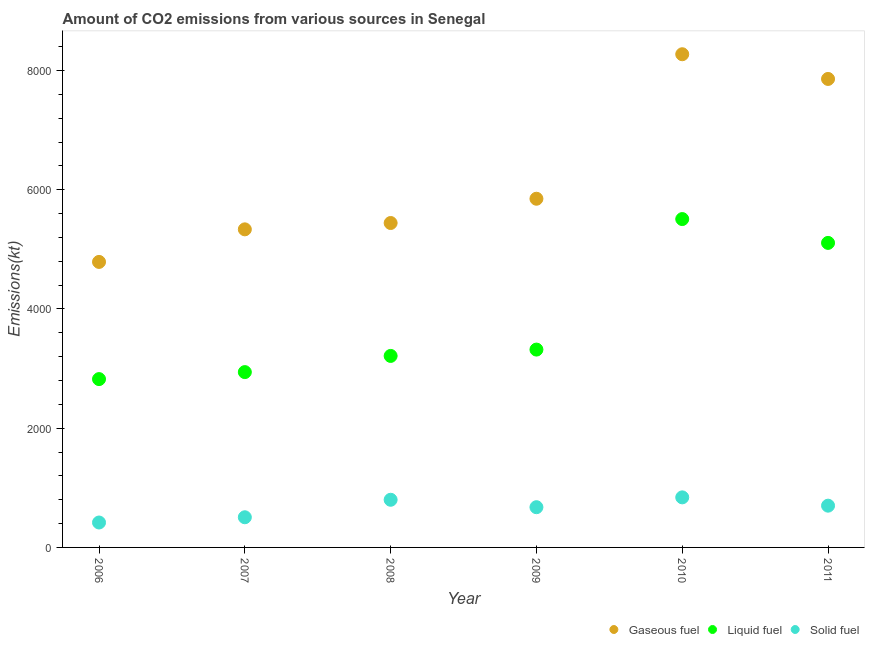How many different coloured dotlines are there?
Make the answer very short. 3. Is the number of dotlines equal to the number of legend labels?
Your answer should be very brief. Yes. What is the amount of co2 emissions from gaseous fuel in 2011?
Provide a short and direct response. 7858.38. Across all years, what is the maximum amount of co2 emissions from gaseous fuel?
Provide a succinct answer. 8272.75. Across all years, what is the minimum amount of co2 emissions from liquid fuel?
Ensure brevity in your answer.  2823.59. In which year was the amount of co2 emissions from gaseous fuel maximum?
Your answer should be very brief. 2010. In which year was the amount of co2 emissions from solid fuel minimum?
Ensure brevity in your answer.  2006. What is the total amount of co2 emissions from gaseous fuel in the graph?
Provide a succinct answer. 3.75e+04. What is the difference between the amount of co2 emissions from liquid fuel in 2007 and that in 2009?
Offer a terse response. -377.7. What is the difference between the amount of co2 emissions from gaseous fuel in 2006 and the amount of co2 emissions from solid fuel in 2008?
Provide a short and direct response. 3989.7. What is the average amount of co2 emissions from solid fuel per year?
Ensure brevity in your answer.  656.39. In the year 2007, what is the difference between the amount of co2 emissions from solid fuel and amount of co2 emissions from gaseous fuel?
Make the answer very short. -4829.44. In how many years, is the amount of co2 emissions from solid fuel greater than 1200 kt?
Your answer should be very brief. 0. What is the ratio of the amount of co2 emissions from solid fuel in 2008 to that in 2010?
Offer a very short reply. 0.95. Is the amount of co2 emissions from liquid fuel in 2007 less than that in 2011?
Offer a terse response. Yes. What is the difference between the highest and the second highest amount of co2 emissions from gaseous fuel?
Your answer should be compact. 414.37. What is the difference between the highest and the lowest amount of co2 emissions from gaseous fuel?
Your answer should be compact. 3483.65. In how many years, is the amount of co2 emissions from gaseous fuel greater than the average amount of co2 emissions from gaseous fuel taken over all years?
Keep it short and to the point. 2. Is the sum of the amount of co2 emissions from liquid fuel in 2010 and 2011 greater than the maximum amount of co2 emissions from solid fuel across all years?
Your answer should be very brief. Yes. Is the amount of co2 emissions from liquid fuel strictly greater than the amount of co2 emissions from solid fuel over the years?
Your answer should be compact. Yes. How many dotlines are there?
Offer a terse response. 3. What is the difference between two consecutive major ticks on the Y-axis?
Give a very brief answer. 2000. Are the values on the major ticks of Y-axis written in scientific E-notation?
Provide a succinct answer. No. Does the graph contain any zero values?
Make the answer very short. No. Where does the legend appear in the graph?
Give a very brief answer. Bottom right. What is the title of the graph?
Give a very brief answer. Amount of CO2 emissions from various sources in Senegal. Does "Capital account" appear as one of the legend labels in the graph?
Provide a short and direct response. No. What is the label or title of the X-axis?
Your answer should be very brief. Year. What is the label or title of the Y-axis?
Keep it short and to the point. Emissions(kt). What is the Emissions(kt) of Gaseous fuel in 2006?
Provide a short and direct response. 4789.1. What is the Emissions(kt) of Liquid fuel in 2006?
Give a very brief answer. 2823.59. What is the Emissions(kt) in Solid fuel in 2006?
Provide a succinct answer. 418.04. What is the Emissions(kt) in Gaseous fuel in 2007?
Offer a terse response. 5335.48. What is the Emissions(kt) of Liquid fuel in 2007?
Offer a terse response. 2940.93. What is the Emissions(kt) in Solid fuel in 2007?
Offer a very short reply. 506.05. What is the Emissions(kt) of Gaseous fuel in 2008?
Offer a very short reply. 5441.83. What is the Emissions(kt) of Liquid fuel in 2008?
Offer a very short reply. 3212.29. What is the Emissions(kt) of Solid fuel in 2008?
Your answer should be compact. 799.41. What is the Emissions(kt) of Gaseous fuel in 2009?
Give a very brief answer. 5848.86. What is the Emissions(kt) in Liquid fuel in 2009?
Offer a very short reply. 3318.64. What is the Emissions(kt) of Solid fuel in 2009?
Give a very brief answer. 674.73. What is the Emissions(kt) in Gaseous fuel in 2010?
Offer a very short reply. 8272.75. What is the Emissions(kt) of Liquid fuel in 2010?
Offer a terse response. 5507.83. What is the Emissions(kt) of Solid fuel in 2010?
Keep it short and to the point. 839.74. What is the Emissions(kt) in Gaseous fuel in 2011?
Make the answer very short. 7858.38. What is the Emissions(kt) of Liquid fuel in 2011?
Offer a very short reply. 5108.13. What is the Emissions(kt) in Solid fuel in 2011?
Provide a short and direct response. 700.4. Across all years, what is the maximum Emissions(kt) of Gaseous fuel?
Your response must be concise. 8272.75. Across all years, what is the maximum Emissions(kt) in Liquid fuel?
Your answer should be compact. 5507.83. Across all years, what is the maximum Emissions(kt) in Solid fuel?
Offer a terse response. 839.74. Across all years, what is the minimum Emissions(kt) of Gaseous fuel?
Keep it short and to the point. 4789.1. Across all years, what is the minimum Emissions(kt) of Liquid fuel?
Offer a very short reply. 2823.59. Across all years, what is the minimum Emissions(kt) in Solid fuel?
Offer a terse response. 418.04. What is the total Emissions(kt) of Gaseous fuel in the graph?
Give a very brief answer. 3.75e+04. What is the total Emissions(kt) of Liquid fuel in the graph?
Offer a very short reply. 2.29e+04. What is the total Emissions(kt) in Solid fuel in the graph?
Your response must be concise. 3938.36. What is the difference between the Emissions(kt) in Gaseous fuel in 2006 and that in 2007?
Your answer should be compact. -546.38. What is the difference between the Emissions(kt) of Liquid fuel in 2006 and that in 2007?
Give a very brief answer. -117.34. What is the difference between the Emissions(kt) of Solid fuel in 2006 and that in 2007?
Your answer should be compact. -88.01. What is the difference between the Emissions(kt) of Gaseous fuel in 2006 and that in 2008?
Provide a succinct answer. -652.73. What is the difference between the Emissions(kt) of Liquid fuel in 2006 and that in 2008?
Provide a short and direct response. -388.7. What is the difference between the Emissions(kt) of Solid fuel in 2006 and that in 2008?
Offer a terse response. -381.37. What is the difference between the Emissions(kt) in Gaseous fuel in 2006 and that in 2009?
Ensure brevity in your answer.  -1059.76. What is the difference between the Emissions(kt) of Liquid fuel in 2006 and that in 2009?
Offer a very short reply. -495.05. What is the difference between the Emissions(kt) of Solid fuel in 2006 and that in 2009?
Offer a very short reply. -256.69. What is the difference between the Emissions(kt) of Gaseous fuel in 2006 and that in 2010?
Give a very brief answer. -3483.65. What is the difference between the Emissions(kt) of Liquid fuel in 2006 and that in 2010?
Provide a short and direct response. -2684.24. What is the difference between the Emissions(kt) of Solid fuel in 2006 and that in 2010?
Give a very brief answer. -421.7. What is the difference between the Emissions(kt) in Gaseous fuel in 2006 and that in 2011?
Keep it short and to the point. -3069.28. What is the difference between the Emissions(kt) in Liquid fuel in 2006 and that in 2011?
Your response must be concise. -2284.54. What is the difference between the Emissions(kt) of Solid fuel in 2006 and that in 2011?
Ensure brevity in your answer.  -282.36. What is the difference between the Emissions(kt) in Gaseous fuel in 2007 and that in 2008?
Keep it short and to the point. -106.34. What is the difference between the Emissions(kt) of Liquid fuel in 2007 and that in 2008?
Your response must be concise. -271.36. What is the difference between the Emissions(kt) of Solid fuel in 2007 and that in 2008?
Your answer should be compact. -293.36. What is the difference between the Emissions(kt) of Gaseous fuel in 2007 and that in 2009?
Ensure brevity in your answer.  -513.38. What is the difference between the Emissions(kt) in Liquid fuel in 2007 and that in 2009?
Make the answer very short. -377.7. What is the difference between the Emissions(kt) of Solid fuel in 2007 and that in 2009?
Ensure brevity in your answer.  -168.68. What is the difference between the Emissions(kt) of Gaseous fuel in 2007 and that in 2010?
Your response must be concise. -2937.27. What is the difference between the Emissions(kt) in Liquid fuel in 2007 and that in 2010?
Keep it short and to the point. -2566.9. What is the difference between the Emissions(kt) of Solid fuel in 2007 and that in 2010?
Your response must be concise. -333.7. What is the difference between the Emissions(kt) of Gaseous fuel in 2007 and that in 2011?
Keep it short and to the point. -2522.9. What is the difference between the Emissions(kt) in Liquid fuel in 2007 and that in 2011?
Offer a terse response. -2167.2. What is the difference between the Emissions(kt) in Solid fuel in 2007 and that in 2011?
Keep it short and to the point. -194.35. What is the difference between the Emissions(kt) of Gaseous fuel in 2008 and that in 2009?
Your answer should be very brief. -407.04. What is the difference between the Emissions(kt) in Liquid fuel in 2008 and that in 2009?
Your answer should be very brief. -106.34. What is the difference between the Emissions(kt) in Solid fuel in 2008 and that in 2009?
Offer a terse response. 124.68. What is the difference between the Emissions(kt) of Gaseous fuel in 2008 and that in 2010?
Provide a succinct answer. -2830.92. What is the difference between the Emissions(kt) in Liquid fuel in 2008 and that in 2010?
Provide a short and direct response. -2295.54. What is the difference between the Emissions(kt) in Solid fuel in 2008 and that in 2010?
Your response must be concise. -40.34. What is the difference between the Emissions(kt) in Gaseous fuel in 2008 and that in 2011?
Your response must be concise. -2416.55. What is the difference between the Emissions(kt) of Liquid fuel in 2008 and that in 2011?
Provide a succinct answer. -1895.84. What is the difference between the Emissions(kt) of Solid fuel in 2008 and that in 2011?
Offer a very short reply. 99.01. What is the difference between the Emissions(kt) in Gaseous fuel in 2009 and that in 2010?
Offer a terse response. -2423.89. What is the difference between the Emissions(kt) of Liquid fuel in 2009 and that in 2010?
Keep it short and to the point. -2189.2. What is the difference between the Emissions(kt) in Solid fuel in 2009 and that in 2010?
Make the answer very short. -165.01. What is the difference between the Emissions(kt) in Gaseous fuel in 2009 and that in 2011?
Provide a succinct answer. -2009.52. What is the difference between the Emissions(kt) in Liquid fuel in 2009 and that in 2011?
Ensure brevity in your answer.  -1789.5. What is the difference between the Emissions(kt) of Solid fuel in 2009 and that in 2011?
Give a very brief answer. -25.67. What is the difference between the Emissions(kt) of Gaseous fuel in 2010 and that in 2011?
Provide a succinct answer. 414.37. What is the difference between the Emissions(kt) of Liquid fuel in 2010 and that in 2011?
Offer a terse response. 399.7. What is the difference between the Emissions(kt) in Solid fuel in 2010 and that in 2011?
Offer a very short reply. 139.35. What is the difference between the Emissions(kt) in Gaseous fuel in 2006 and the Emissions(kt) in Liquid fuel in 2007?
Keep it short and to the point. 1848.17. What is the difference between the Emissions(kt) of Gaseous fuel in 2006 and the Emissions(kt) of Solid fuel in 2007?
Keep it short and to the point. 4283.06. What is the difference between the Emissions(kt) of Liquid fuel in 2006 and the Emissions(kt) of Solid fuel in 2007?
Ensure brevity in your answer.  2317.54. What is the difference between the Emissions(kt) of Gaseous fuel in 2006 and the Emissions(kt) of Liquid fuel in 2008?
Your answer should be compact. 1576.81. What is the difference between the Emissions(kt) in Gaseous fuel in 2006 and the Emissions(kt) in Solid fuel in 2008?
Offer a terse response. 3989.7. What is the difference between the Emissions(kt) in Liquid fuel in 2006 and the Emissions(kt) in Solid fuel in 2008?
Offer a terse response. 2024.18. What is the difference between the Emissions(kt) of Gaseous fuel in 2006 and the Emissions(kt) of Liquid fuel in 2009?
Offer a very short reply. 1470.47. What is the difference between the Emissions(kt) in Gaseous fuel in 2006 and the Emissions(kt) in Solid fuel in 2009?
Provide a short and direct response. 4114.37. What is the difference between the Emissions(kt) of Liquid fuel in 2006 and the Emissions(kt) of Solid fuel in 2009?
Your answer should be compact. 2148.86. What is the difference between the Emissions(kt) of Gaseous fuel in 2006 and the Emissions(kt) of Liquid fuel in 2010?
Your answer should be very brief. -718.73. What is the difference between the Emissions(kt) in Gaseous fuel in 2006 and the Emissions(kt) in Solid fuel in 2010?
Offer a very short reply. 3949.36. What is the difference between the Emissions(kt) of Liquid fuel in 2006 and the Emissions(kt) of Solid fuel in 2010?
Your answer should be very brief. 1983.85. What is the difference between the Emissions(kt) of Gaseous fuel in 2006 and the Emissions(kt) of Liquid fuel in 2011?
Your answer should be compact. -319.03. What is the difference between the Emissions(kt) in Gaseous fuel in 2006 and the Emissions(kt) in Solid fuel in 2011?
Your answer should be compact. 4088.7. What is the difference between the Emissions(kt) of Liquid fuel in 2006 and the Emissions(kt) of Solid fuel in 2011?
Offer a very short reply. 2123.19. What is the difference between the Emissions(kt) in Gaseous fuel in 2007 and the Emissions(kt) in Liquid fuel in 2008?
Your answer should be compact. 2123.19. What is the difference between the Emissions(kt) of Gaseous fuel in 2007 and the Emissions(kt) of Solid fuel in 2008?
Provide a succinct answer. 4536.08. What is the difference between the Emissions(kt) of Liquid fuel in 2007 and the Emissions(kt) of Solid fuel in 2008?
Keep it short and to the point. 2141.53. What is the difference between the Emissions(kt) of Gaseous fuel in 2007 and the Emissions(kt) of Liquid fuel in 2009?
Give a very brief answer. 2016.85. What is the difference between the Emissions(kt) in Gaseous fuel in 2007 and the Emissions(kt) in Solid fuel in 2009?
Ensure brevity in your answer.  4660.76. What is the difference between the Emissions(kt) in Liquid fuel in 2007 and the Emissions(kt) in Solid fuel in 2009?
Offer a very short reply. 2266.21. What is the difference between the Emissions(kt) of Gaseous fuel in 2007 and the Emissions(kt) of Liquid fuel in 2010?
Your answer should be compact. -172.35. What is the difference between the Emissions(kt) of Gaseous fuel in 2007 and the Emissions(kt) of Solid fuel in 2010?
Provide a succinct answer. 4495.74. What is the difference between the Emissions(kt) of Liquid fuel in 2007 and the Emissions(kt) of Solid fuel in 2010?
Your answer should be very brief. 2101.19. What is the difference between the Emissions(kt) in Gaseous fuel in 2007 and the Emissions(kt) in Liquid fuel in 2011?
Your answer should be compact. 227.35. What is the difference between the Emissions(kt) in Gaseous fuel in 2007 and the Emissions(kt) in Solid fuel in 2011?
Your response must be concise. 4635.09. What is the difference between the Emissions(kt) of Liquid fuel in 2007 and the Emissions(kt) of Solid fuel in 2011?
Offer a very short reply. 2240.54. What is the difference between the Emissions(kt) in Gaseous fuel in 2008 and the Emissions(kt) in Liquid fuel in 2009?
Keep it short and to the point. 2123.19. What is the difference between the Emissions(kt) in Gaseous fuel in 2008 and the Emissions(kt) in Solid fuel in 2009?
Ensure brevity in your answer.  4767.1. What is the difference between the Emissions(kt) of Liquid fuel in 2008 and the Emissions(kt) of Solid fuel in 2009?
Ensure brevity in your answer.  2537.56. What is the difference between the Emissions(kt) of Gaseous fuel in 2008 and the Emissions(kt) of Liquid fuel in 2010?
Keep it short and to the point. -66.01. What is the difference between the Emissions(kt) of Gaseous fuel in 2008 and the Emissions(kt) of Solid fuel in 2010?
Your answer should be very brief. 4602.09. What is the difference between the Emissions(kt) of Liquid fuel in 2008 and the Emissions(kt) of Solid fuel in 2010?
Your answer should be very brief. 2372.55. What is the difference between the Emissions(kt) in Gaseous fuel in 2008 and the Emissions(kt) in Liquid fuel in 2011?
Make the answer very short. 333.7. What is the difference between the Emissions(kt) of Gaseous fuel in 2008 and the Emissions(kt) of Solid fuel in 2011?
Keep it short and to the point. 4741.43. What is the difference between the Emissions(kt) of Liquid fuel in 2008 and the Emissions(kt) of Solid fuel in 2011?
Provide a succinct answer. 2511.89. What is the difference between the Emissions(kt) in Gaseous fuel in 2009 and the Emissions(kt) in Liquid fuel in 2010?
Provide a succinct answer. 341.03. What is the difference between the Emissions(kt) of Gaseous fuel in 2009 and the Emissions(kt) of Solid fuel in 2010?
Provide a succinct answer. 5009.12. What is the difference between the Emissions(kt) of Liquid fuel in 2009 and the Emissions(kt) of Solid fuel in 2010?
Offer a terse response. 2478.89. What is the difference between the Emissions(kt) of Gaseous fuel in 2009 and the Emissions(kt) of Liquid fuel in 2011?
Offer a very short reply. 740.73. What is the difference between the Emissions(kt) of Gaseous fuel in 2009 and the Emissions(kt) of Solid fuel in 2011?
Your answer should be very brief. 5148.47. What is the difference between the Emissions(kt) of Liquid fuel in 2009 and the Emissions(kt) of Solid fuel in 2011?
Your response must be concise. 2618.24. What is the difference between the Emissions(kt) in Gaseous fuel in 2010 and the Emissions(kt) in Liquid fuel in 2011?
Offer a very short reply. 3164.62. What is the difference between the Emissions(kt) in Gaseous fuel in 2010 and the Emissions(kt) in Solid fuel in 2011?
Provide a short and direct response. 7572.35. What is the difference between the Emissions(kt) in Liquid fuel in 2010 and the Emissions(kt) in Solid fuel in 2011?
Ensure brevity in your answer.  4807.44. What is the average Emissions(kt) of Gaseous fuel per year?
Give a very brief answer. 6257.74. What is the average Emissions(kt) in Liquid fuel per year?
Your answer should be compact. 3818.57. What is the average Emissions(kt) in Solid fuel per year?
Provide a short and direct response. 656.39. In the year 2006, what is the difference between the Emissions(kt) in Gaseous fuel and Emissions(kt) in Liquid fuel?
Your answer should be compact. 1965.51. In the year 2006, what is the difference between the Emissions(kt) of Gaseous fuel and Emissions(kt) of Solid fuel?
Your answer should be compact. 4371.06. In the year 2006, what is the difference between the Emissions(kt) of Liquid fuel and Emissions(kt) of Solid fuel?
Provide a succinct answer. 2405.55. In the year 2007, what is the difference between the Emissions(kt) of Gaseous fuel and Emissions(kt) of Liquid fuel?
Provide a succinct answer. 2394.55. In the year 2007, what is the difference between the Emissions(kt) of Gaseous fuel and Emissions(kt) of Solid fuel?
Ensure brevity in your answer.  4829.44. In the year 2007, what is the difference between the Emissions(kt) in Liquid fuel and Emissions(kt) in Solid fuel?
Make the answer very short. 2434.89. In the year 2008, what is the difference between the Emissions(kt) of Gaseous fuel and Emissions(kt) of Liquid fuel?
Give a very brief answer. 2229.54. In the year 2008, what is the difference between the Emissions(kt) of Gaseous fuel and Emissions(kt) of Solid fuel?
Ensure brevity in your answer.  4642.42. In the year 2008, what is the difference between the Emissions(kt) of Liquid fuel and Emissions(kt) of Solid fuel?
Provide a short and direct response. 2412.89. In the year 2009, what is the difference between the Emissions(kt) of Gaseous fuel and Emissions(kt) of Liquid fuel?
Your response must be concise. 2530.23. In the year 2009, what is the difference between the Emissions(kt) in Gaseous fuel and Emissions(kt) in Solid fuel?
Your answer should be compact. 5174.14. In the year 2009, what is the difference between the Emissions(kt) in Liquid fuel and Emissions(kt) in Solid fuel?
Your response must be concise. 2643.91. In the year 2010, what is the difference between the Emissions(kt) in Gaseous fuel and Emissions(kt) in Liquid fuel?
Give a very brief answer. 2764.92. In the year 2010, what is the difference between the Emissions(kt) in Gaseous fuel and Emissions(kt) in Solid fuel?
Your response must be concise. 7433.01. In the year 2010, what is the difference between the Emissions(kt) in Liquid fuel and Emissions(kt) in Solid fuel?
Provide a succinct answer. 4668.09. In the year 2011, what is the difference between the Emissions(kt) in Gaseous fuel and Emissions(kt) in Liquid fuel?
Your response must be concise. 2750.25. In the year 2011, what is the difference between the Emissions(kt) in Gaseous fuel and Emissions(kt) in Solid fuel?
Ensure brevity in your answer.  7157.98. In the year 2011, what is the difference between the Emissions(kt) in Liquid fuel and Emissions(kt) in Solid fuel?
Offer a terse response. 4407.73. What is the ratio of the Emissions(kt) of Gaseous fuel in 2006 to that in 2007?
Provide a short and direct response. 0.9. What is the ratio of the Emissions(kt) of Liquid fuel in 2006 to that in 2007?
Offer a very short reply. 0.96. What is the ratio of the Emissions(kt) of Solid fuel in 2006 to that in 2007?
Ensure brevity in your answer.  0.83. What is the ratio of the Emissions(kt) in Gaseous fuel in 2006 to that in 2008?
Provide a succinct answer. 0.88. What is the ratio of the Emissions(kt) of Liquid fuel in 2006 to that in 2008?
Offer a terse response. 0.88. What is the ratio of the Emissions(kt) of Solid fuel in 2006 to that in 2008?
Provide a short and direct response. 0.52. What is the ratio of the Emissions(kt) in Gaseous fuel in 2006 to that in 2009?
Your answer should be very brief. 0.82. What is the ratio of the Emissions(kt) of Liquid fuel in 2006 to that in 2009?
Your answer should be very brief. 0.85. What is the ratio of the Emissions(kt) in Solid fuel in 2006 to that in 2009?
Provide a succinct answer. 0.62. What is the ratio of the Emissions(kt) of Gaseous fuel in 2006 to that in 2010?
Offer a very short reply. 0.58. What is the ratio of the Emissions(kt) of Liquid fuel in 2006 to that in 2010?
Provide a succinct answer. 0.51. What is the ratio of the Emissions(kt) of Solid fuel in 2006 to that in 2010?
Your answer should be compact. 0.5. What is the ratio of the Emissions(kt) in Gaseous fuel in 2006 to that in 2011?
Provide a short and direct response. 0.61. What is the ratio of the Emissions(kt) of Liquid fuel in 2006 to that in 2011?
Provide a succinct answer. 0.55. What is the ratio of the Emissions(kt) of Solid fuel in 2006 to that in 2011?
Provide a short and direct response. 0.6. What is the ratio of the Emissions(kt) of Gaseous fuel in 2007 to that in 2008?
Keep it short and to the point. 0.98. What is the ratio of the Emissions(kt) of Liquid fuel in 2007 to that in 2008?
Your answer should be very brief. 0.92. What is the ratio of the Emissions(kt) of Solid fuel in 2007 to that in 2008?
Ensure brevity in your answer.  0.63. What is the ratio of the Emissions(kt) of Gaseous fuel in 2007 to that in 2009?
Your response must be concise. 0.91. What is the ratio of the Emissions(kt) of Liquid fuel in 2007 to that in 2009?
Ensure brevity in your answer.  0.89. What is the ratio of the Emissions(kt) in Solid fuel in 2007 to that in 2009?
Ensure brevity in your answer.  0.75. What is the ratio of the Emissions(kt) in Gaseous fuel in 2007 to that in 2010?
Make the answer very short. 0.64. What is the ratio of the Emissions(kt) in Liquid fuel in 2007 to that in 2010?
Give a very brief answer. 0.53. What is the ratio of the Emissions(kt) of Solid fuel in 2007 to that in 2010?
Your answer should be very brief. 0.6. What is the ratio of the Emissions(kt) of Gaseous fuel in 2007 to that in 2011?
Offer a very short reply. 0.68. What is the ratio of the Emissions(kt) in Liquid fuel in 2007 to that in 2011?
Provide a short and direct response. 0.58. What is the ratio of the Emissions(kt) in Solid fuel in 2007 to that in 2011?
Ensure brevity in your answer.  0.72. What is the ratio of the Emissions(kt) of Gaseous fuel in 2008 to that in 2009?
Ensure brevity in your answer.  0.93. What is the ratio of the Emissions(kt) in Solid fuel in 2008 to that in 2009?
Your response must be concise. 1.18. What is the ratio of the Emissions(kt) in Gaseous fuel in 2008 to that in 2010?
Ensure brevity in your answer.  0.66. What is the ratio of the Emissions(kt) of Liquid fuel in 2008 to that in 2010?
Give a very brief answer. 0.58. What is the ratio of the Emissions(kt) of Solid fuel in 2008 to that in 2010?
Make the answer very short. 0.95. What is the ratio of the Emissions(kt) in Gaseous fuel in 2008 to that in 2011?
Offer a very short reply. 0.69. What is the ratio of the Emissions(kt) of Liquid fuel in 2008 to that in 2011?
Offer a very short reply. 0.63. What is the ratio of the Emissions(kt) in Solid fuel in 2008 to that in 2011?
Provide a succinct answer. 1.14. What is the ratio of the Emissions(kt) of Gaseous fuel in 2009 to that in 2010?
Keep it short and to the point. 0.71. What is the ratio of the Emissions(kt) in Liquid fuel in 2009 to that in 2010?
Provide a succinct answer. 0.6. What is the ratio of the Emissions(kt) of Solid fuel in 2009 to that in 2010?
Offer a very short reply. 0.8. What is the ratio of the Emissions(kt) of Gaseous fuel in 2009 to that in 2011?
Ensure brevity in your answer.  0.74. What is the ratio of the Emissions(kt) in Liquid fuel in 2009 to that in 2011?
Give a very brief answer. 0.65. What is the ratio of the Emissions(kt) in Solid fuel in 2009 to that in 2011?
Your answer should be very brief. 0.96. What is the ratio of the Emissions(kt) in Gaseous fuel in 2010 to that in 2011?
Provide a succinct answer. 1.05. What is the ratio of the Emissions(kt) in Liquid fuel in 2010 to that in 2011?
Provide a short and direct response. 1.08. What is the ratio of the Emissions(kt) in Solid fuel in 2010 to that in 2011?
Give a very brief answer. 1.2. What is the difference between the highest and the second highest Emissions(kt) of Gaseous fuel?
Ensure brevity in your answer.  414.37. What is the difference between the highest and the second highest Emissions(kt) in Liquid fuel?
Offer a terse response. 399.7. What is the difference between the highest and the second highest Emissions(kt) in Solid fuel?
Provide a short and direct response. 40.34. What is the difference between the highest and the lowest Emissions(kt) of Gaseous fuel?
Make the answer very short. 3483.65. What is the difference between the highest and the lowest Emissions(kt) in Liquid fuel?
Your response must be concise. 2684.24. What is the difference between the highest and the lowest Emissions(kt) of Solid fuel?
Make the answer very short. 421.7. 